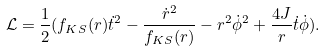<formula> <loc_0><loc_0><loc_500><loc_500>\mathcal { L } = \frac { 1 } { 2 } ( f _ { K S } ( r ) \dot { t } ^ { 2 } - \frac { \dot { r } ^ { 2 } } { f _ { K S } ( r ) } - r ^ { 2 } \dot { \phi } ^ { 2 } + \frac { 4 J } { r } \dot { t } \dot { \phi } ) .</formula> 